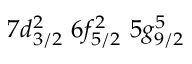<formula> <loc_0><loc_0><loc_500><loc_500>7 d _ { 3 / 2 } ^ { 2 } \, 6 f _ { 5 / 2 } ^ { 2 } \, 5 g _ { 9 / 2 } ^ { 5 }</formula> 